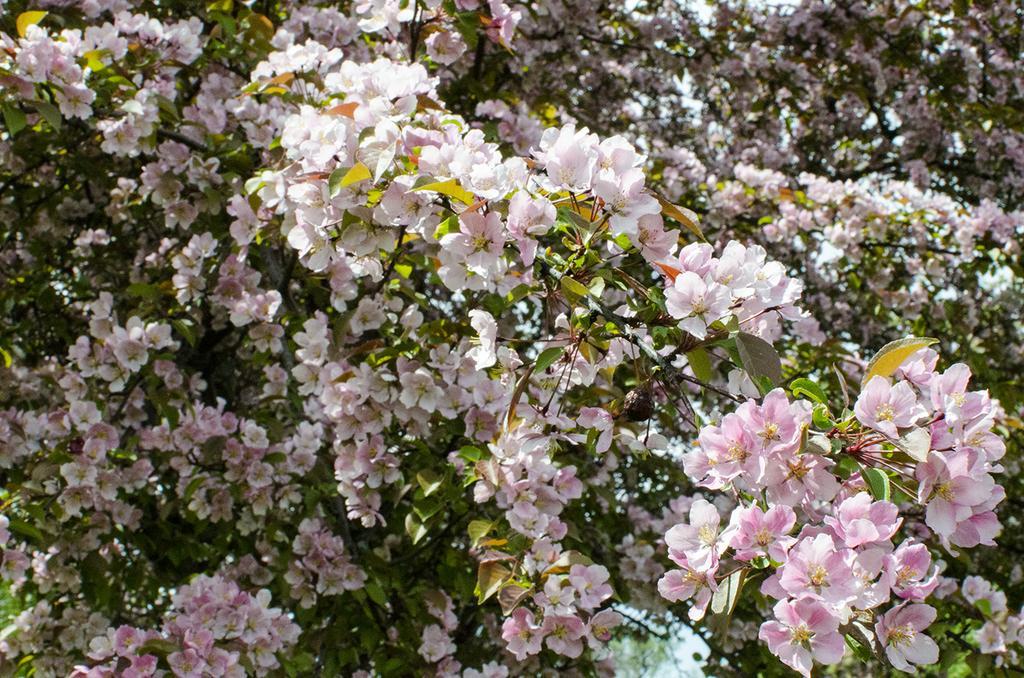Could you give a brief overview of what you see in this image? In this image we can see a group of plants with the bunch of flowers to them. 